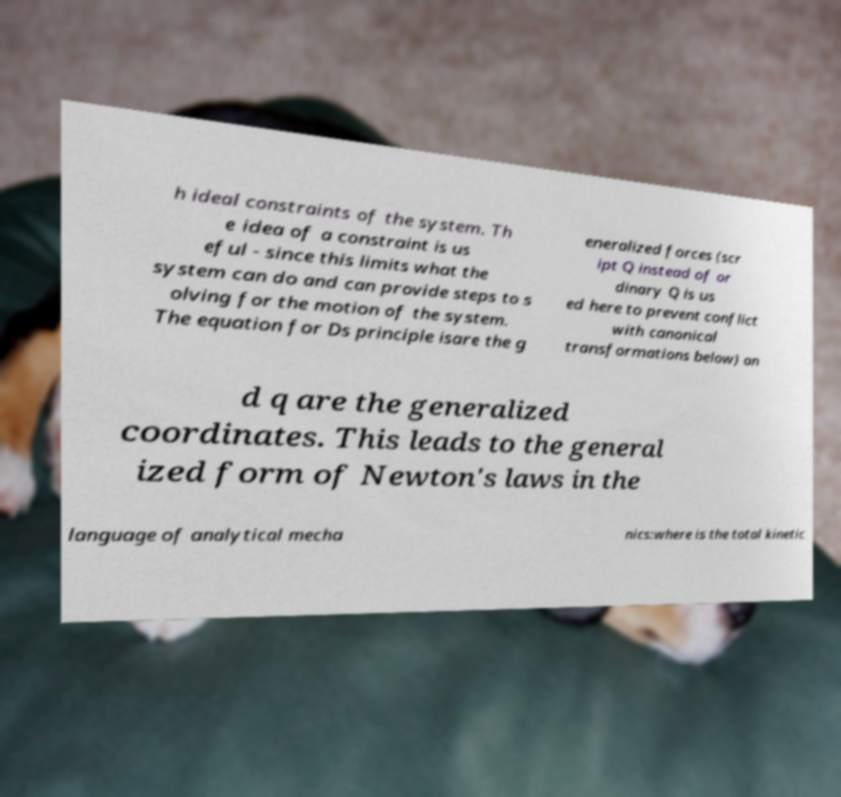Could you assist in decoding the text presented in this image and type it out clearly? h ideal constraints of the system. Th e idea of a constraint is us eful - since this limits what the system can do and can provide steps to s olving for the motion of the system. The equation for Ds principle isare the g eneralized forces (scr ipt Q instead of or dinary Q is us ed here to prevent conflict with canonical transformations below) an d q are the generalized coordinates. This leads to the general ized form of Newton's laws in the language of analytical mecha nics:where is the total kinetic 